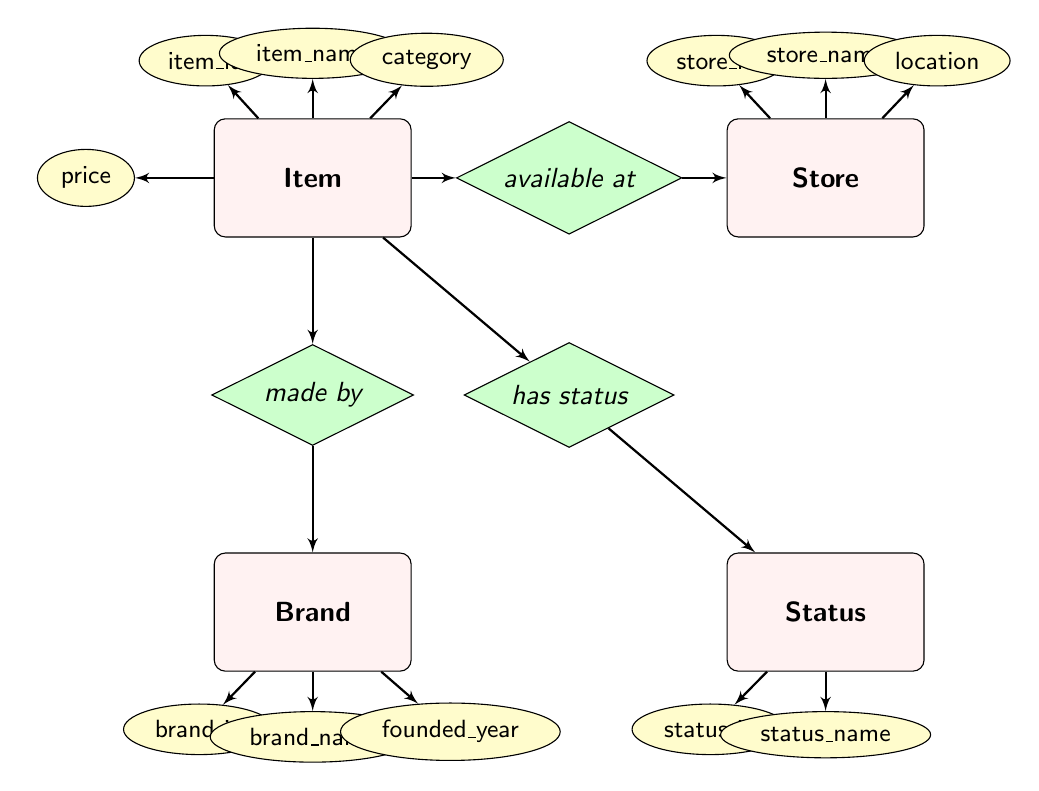What is the item price of the Floral Dress? The Floral Dress has an attribute for price, which is indicated directly in the diagram within the Item entity. It states that the price is 89.99.
Answer: 89.99 Where is H&M located? The location of H&M is specified as an attribute in the Store entity in the diagram. It indicates that H&M is located in Rotterdam.
Answer: Rotterdam How many items are listed in the diagram? To find the number of items, we look at the Item entity. There are two items shown — the Floral Dress and Party Heels.
Answer: 2 Which brand is the Floral Dress made by? The relationship "made by" shows the connection between the Item entity (Floral Dress) and the Brand entity. The diagram specifies that the Floral Dress is made by Gucci.
Answer: Gucci What status does the Party Heels have? The status of the Party Heels is linked through the "has status" relationship to the Status entity. According to the diagram, the Party Heels have the status of "Purchased."
Answer: Purchased Which store has the item named “Party Heels”? To find this, we check the availability relationship. The Party Heels are linked to the Store entity, which specifies that they are available at H&M.
Answer: H&M Which year was Christian Louboutin founded? The founded year for brands is an attribute in the Brand entity. The diagram indicates that Christian Louboutin was founded in 1991.
Answer: 1991 What is the status_id for items that are "Wanted"? The diagram shows the Status entity with an attribute status_id. The status "Wanted" corresponds to status_id 1.
Answer: 1 How many relationships are there connecting the Item entity to other entities? The Item entity connects to three other entities via relationships: available at, made by, and has status. Counting these gives us three relationships.
Answer: 3 